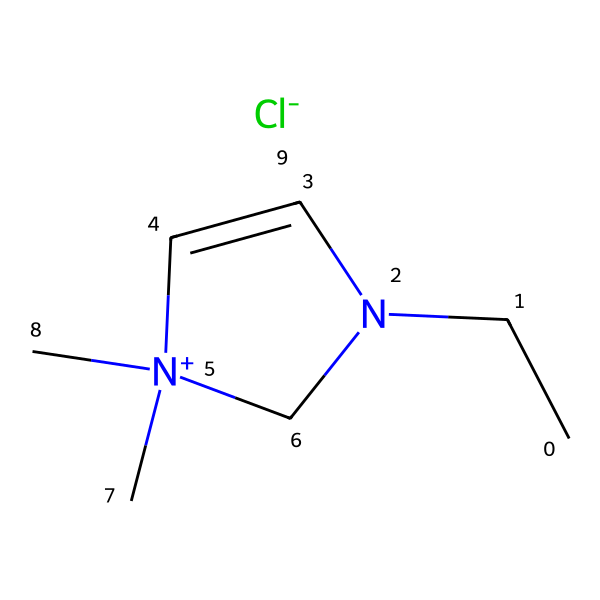What is the molecular formula of this ionic liquid? By analyzing the SMILES representation, we can identify the components: there are carbon (C), hydrogen (H), chlorine (Cl), and nitrogen (N) atoms. Counting them yields C7H11ClN2.
Answer: C7H11ClN2 How many nitrogen atoms are present in the structure? In the given SMILES, we see two nitrogen atoms represented by 'N', indicating their presence.
Answer: 2 What type of ions does this ionic liquid consist of? The structure contains a quaternary ammonium ion represented by the positively charged nitrogen and a chloride ion (-Cl) as the anion, indicating the ionic nature of this liquid.
Answer: quaternary ammonium ion and chloride ion What characteristic property does the presence of the quaternary nitrogen suggest? The presence of a quaternary nitrogen in the structure usually indicates that the ionic liquid has low volatility, which is a significant physical property when used for cleaning artifacts.
Answer: low volatility What is the significance of using ionic liquids in cleaning ancient artifacts? Ionic liquids are particularly effective in cleaning artifacts due to their ability to dissolve a wide range of organic and inorganic materials without damaging the artifacts themselves, due to their tunable properties.
Answer: effective cleaning power Which part of the ion contributes to the solvation properties of this ionic liquid? The quaternary ammonium part of the molecule enhances solvation properties due to its ability to interact with various polar and non-polar substances, which is essential for effectively cleaning artifacts.
Answer: quaternary ammonium part 